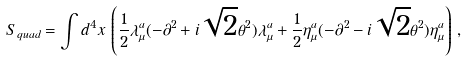<formula> <loc_0><loc_0><loc_500><loc_500>S _ { q u a d } = \int d ^ { 4 } x \, \left ( \frac { 1 } { 2 } \lambda ^ { a } _ { \mu } ( - \partial ^ { 2 } + i \sqrt { 2 } \theta ^ { 2 } ) \lambda ^ { a } _ { \mu } + \frac { 1 } { 2 } \eta ^ { a } _ { \mu } ( - \partial ^ { 2 } - i \sqrt { 2 } \theta ^ { 2 } ) \eta ^ { a } _ { \mu } \right ) \, ,</formula> 